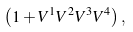Convert formula to latex. <formula><loc_0><loc_0><loc_500><loc_500>\left ( 1 + V ^ { 1 } V ^ { 2 } V ^ { 3 } V ^ { 4 } \right ) ,</formula> 